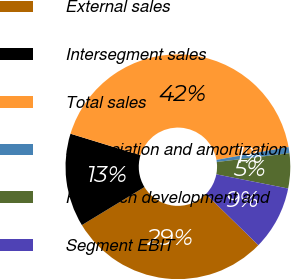Convert chart. <chart><loc_0><loc_0><loc_500><loc_500><pie_chart><fcel>External sales<fcel>Intersegment sales<fcel>Total sales<fcel>Depreciation and amortization<fcel>Research development and<fcel>Segment EBIT<nl><fcel>29.01%<fcel>13.44%<fcel>42.45%<fcel>0.88%<fcel>5.03%<fcel>9.19%<nl></chart> 